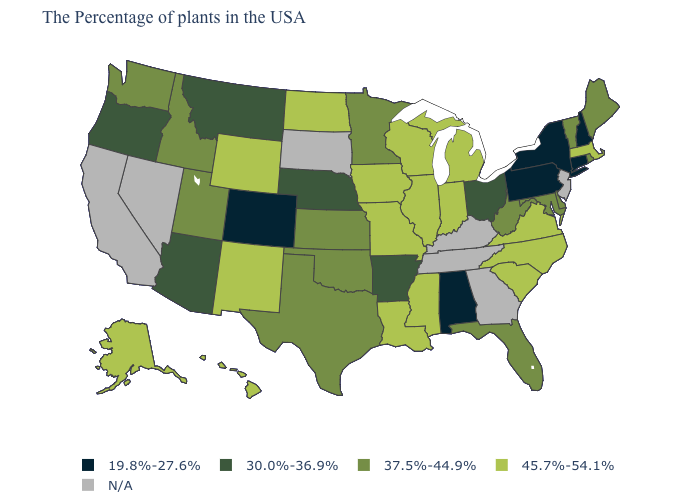What is the highest value in the USA?
Keep it brief. 45.7%-54.1%. What is the highest value in states that border West Virginia?
Concise answer only. 45.7%-54.1%. What is the value of Georgia?
Keep it brief. N/A. What is the value of Wyoming?
Answer briefly. 45.7%-54.1%. Does Pennsylvania have the lowest value in the USA?
Be succinct. Yes. Name the states that have a value in the range 19.8%-27.6%?
Short answer required. New Hampshire, Connecticut, New York, Pennsylvania, Alabama, Colorado. What is the value of Washington?
Write a very short answer. 37.5%-44.9%. Name the states that have a value in the range 30.0%-36.9%?
Be succinct. Ohio, Arkansas, Nebraska, Montana, Arizona, Oregon. What is the highest value in the USA?
Quick response, please. 45.7%-54.1%. What is the value of Oregon?
Keep it brief. 30.0%-36.9%. Does Ohio have the lowest value in the MidWest?
Give a very brief answer. Yes. Name the states that have a value in the range 37.5%-44.9%?
Keep it brief. Maine, Rhode Island, Vermont, Delaware, Maryland, West Virginia, Florida, Minnesota, Kansas, Oklahoma, Texas, Utah, Idaho, Washington. What is the lowest value in states that border Pennsylvania?
Answer briefly. 19.8%-27.6%. Name the states that have a value in the range 19.8%-27.6%?
Answer briefly. New Hampshire, Connecticut, New York, Pennsylvania, Alabama, Colorado. Name the states that have a value in the range 19.8%-27.6%?
Concise answer only. New Hampshire, Connecticut, New York, Pennsylvania, Alabama, Colorado. 